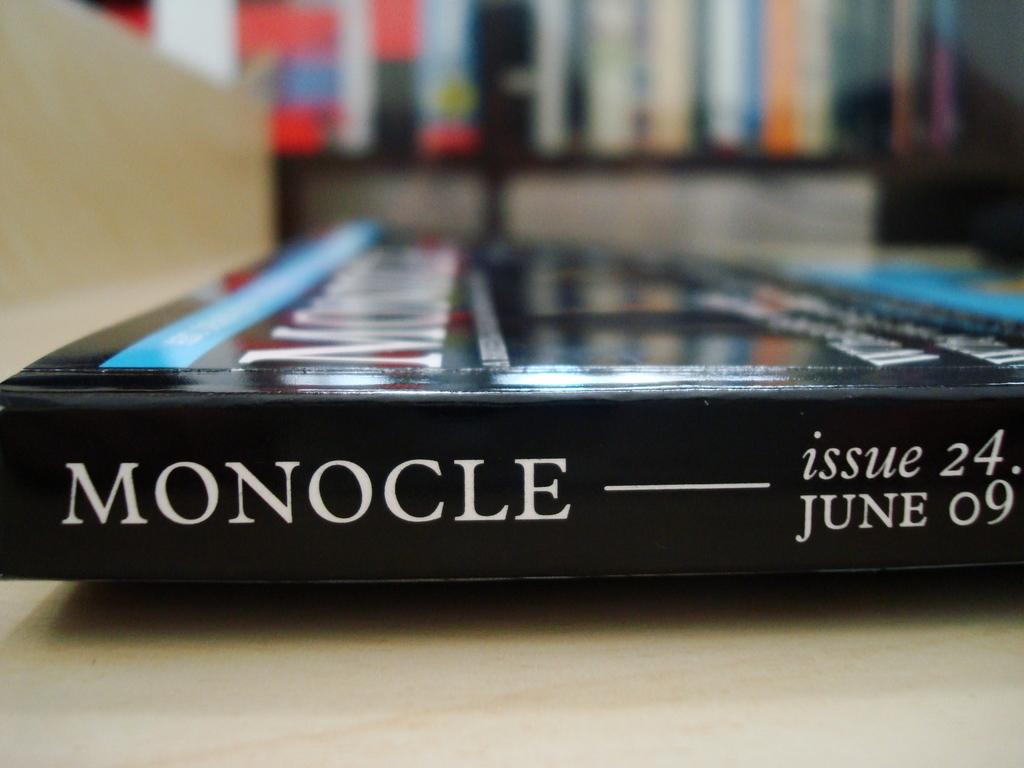<image>
Create a compact narrative representing the image presented. Issue 24 of Monocle lies on a table unopened. 